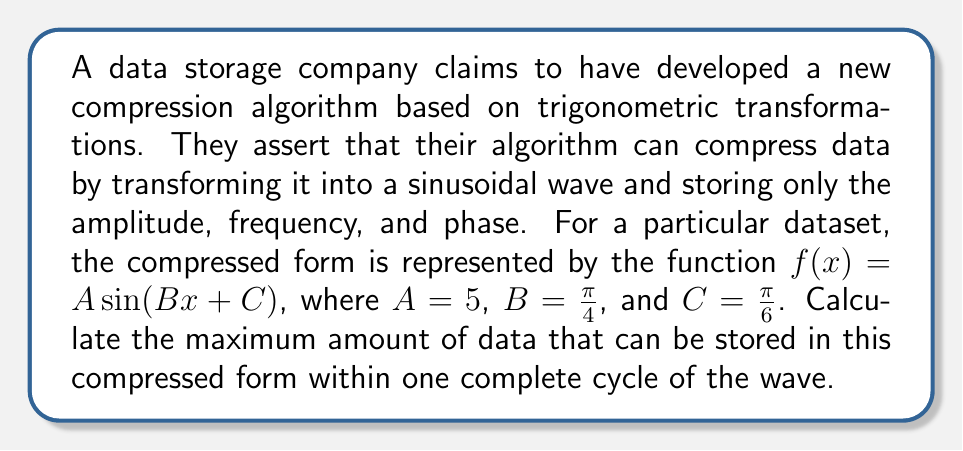What is the answer to this math problem? To solve this problem, we need to follow these steps:

1) First, recall that one complete cycle of a sine wave occurs over a period of $2\pi$ radians.

2) For the given function $f(x) = A \sin(Bx + C)$, the period is determined by the coefficient $B$. The period $T$ is given by:

   $$T = \frac{2\pi}{B}$$

3) In this case, $B = \frac{\pi}{4}$, so:

   $$T = \frac{2\pi}{\frac{\pi}{4}} = 8$$

4) This means that one complete cycle occurs over an interval of length 8.

5) The maximum amount of data stored corresponds to the maximum value of the function over this interval. For a sine function, the maximum value is equal to the amplitude $A$.

6) In this case, $A = 5$.

Therefore, the maximum amount of data that can be stored in this compressed form within one complete cycle is 5 units.
Answer: 5 units 